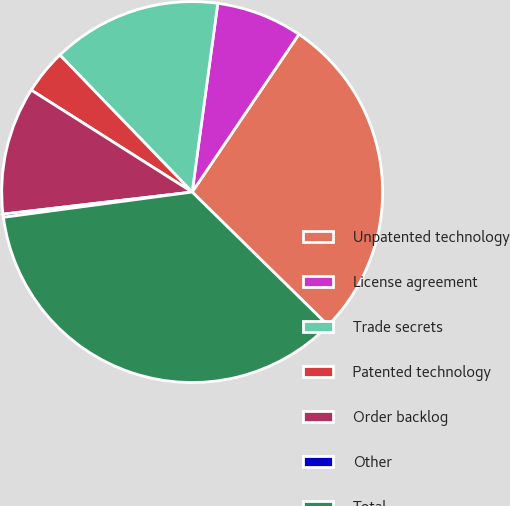Convert chart. <chart><loc_0><loc_0><loc_500><loc_500><pie_chart><fcel>Unpatented technology<fcel>License agreement<fcel>Trade secrets<fcel>Patented technology<fcel>Order backlog<fcel>Other<fcel>Total<nl><fcel>27.89%<fcel>7.32%<fcel>14.37%<fcel>3.79%<fcel>10.84%<fcel>0.27%<fcel>35.53%<nl></chart> 